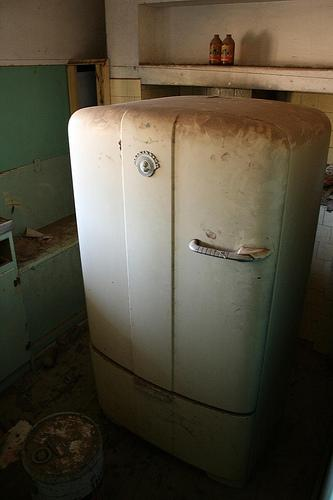Question: who is by the shelf?
Choices:
A. Man.
B. No one.
C. Woman.
D. Girl.
Answer with the letter. Answer: B Question: what is on top of the refrigerator?
Choices:
A. Food.
B. Dirt.
C. Basket.
D. Fruit.
Answer with the letter. Answer: B Question: how many bottles are on the shelf?
Choices:
A. Two.
B. One.
C. Three.
D. Five.
Answer with the letter. Answer: A 